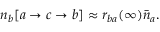Convert formula to latex. <formula><loc_0><loc_0><loc_500><loc_500>n _ { b } [ a \rightarrow c \rightarrow b ] \approx r _ { b a } ( \infty ) { \bar { n } } _ { a } .</formula> 